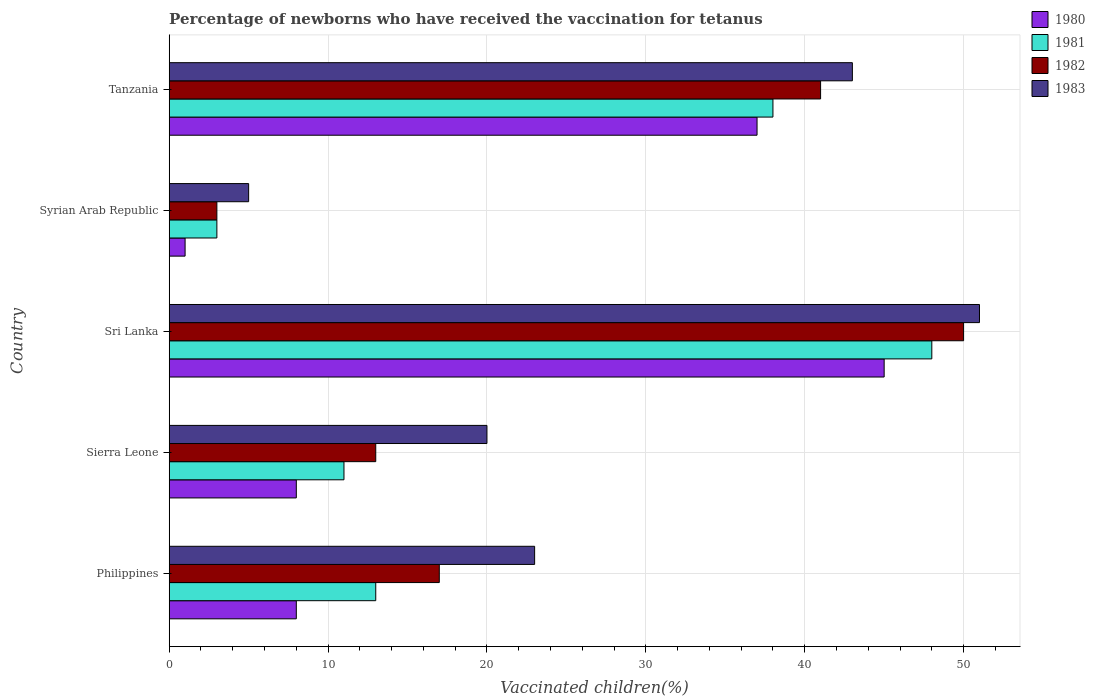Are the number of bars per tick equal to the number of legend labels?
Ensure brevity in your answer.  Yes. How many bars are there on the 1st tick from the bottom?
Your answer should be very brief. 4. What is the label of the 3rd group of bars from the top?
Your answer should be compact. Sri Lanka. In which country was the percentage of vaccinated children in 1983 maximum?
Offer a very short reply. Sri Lanka. In which country was the percentage of vaccinated children in 1982 minimum?
Keep it short and to the point. Syrian Arab Republic. What is the total percentage of vaccinated children in 1982 in the graph?
Your answer should be compact. 124. What is the difference between the percentage of vaccinated children in 1980 in Sri Lanka and the percentage of vaccinated children in 1981 in Philippines?
Ensure brevity in your answer.  32. What is the average percentage of vaccinated children in 1983 per country?
Your answer should be very brief. 28.4. In how many countries, is the percentage of vaccinated children in 1983 greater than 34 %?
Give a very brief answer. 2. What is the ratio of the percentage of vaccinated children in 1983 in Philippines to that in Tanzania?
Your answer should be very brief. 0.53. Is the percentage of vaccinated children in 1981 in Sierra Leone less than that in Tanzania?
Give a very brief answer. Yes. Is the difference between the percentage of vaccinated children in 1981 in Sri Lanka and Tanzania greater than the difference between the percentage of vaccinated children in 1982 in Sri Lanka and Tanzania?
Provide a succinct answer. Yes. What is the difference between the highest and the second highest percentage of vaccinated children in 1982?
Make the answer very short. 9. What is the difference between the highest and the lowest percentage of vaccinated children in 1983?
Your answer should be compact. 46. In how many countries, is the percentage of vaccinated children in 1981 greater than the average percentage of vaccinated children in 1981 taken over all countries?
Provide a short and direct response. 2. Is it the case that in every country, the sum of the percentage of vaccinated children in 1981 and percentage of vaccinated children in 1982 is greater than the sum of percentage of vaccinated children in 1980 and percentage of vaccinated children in 1983?
Make the answer very short. No. What does the 3rd bar from the top in Philippines represents?
Ensure brevity in your answer.  1981. What does the 1st bar from the bottom in Philippines represents?
Ensure brevity in your answer.  1980. Is it the case that in every country, the sum of the percentage of vaccinated children in 1983 and percentage of vaccinated children in 1980 is greater than the percentage of vaccinated children in 1981?
Provide a succinct answer. Yes. How many bars are there?
Your answer should be compact. 20. What is the difference between two consecutive major ticks on the X-axis?
Your answer should be compact. 10. Are the values on the major ticks of X-axis written in scientific E-notation?
Offer a terse response. No. Does the graph contain grids?
Give a very brief answer. Yes. How many legend labels are there?
Give a very brief answer. 4. How are the legend labels stacked?
Offer a terse response. Vertical. What is the title of the graph?
Offer a very short reply. Percentage of newborns who have received the vaccination for tetanus. What is the label or title of the X-axis?
Keep it short and to the point. Vaccinated children(%). What is the Vaccinated children(%) in 1982 in Philippines?
Make the answer very short. 17. What is the Vaccinated children(%) of 1983 in Philippines?
Offer a terse response. 23. What is the Vaccinated children(%) in 1980 in Sierra Leone?
Ensure brevity in your answer.  8. What is the Vaccinated children(%) in 1983 in Sierra Leone?
Ensure brevity in your answer.  20. What is the Vaccinated children(%) of 1980 in Sri Lanka?
Ensure brevity in your answer.  45. What is the Vaccinated children(%) in 1981 in Sri Lanka?
Make the answer very short. 48. What is the Vaccinated children(%) of 1982 in Sri Lanka?
Your answer should be compact. 50. What is the Vaccinated children(%) of 1981 in Syrian Arab Republic?
Offer a terse response. 3. What is the Vaccinated children(%) in 1982 in Syrian Arab Republic?
Your response must be concise. 3. What is the Vaccinated children(%) in 1981 in Tanzania?
Your response must be concise. 38. What is the Vaccinated children(%) in 1983 in Tanzania?
Provide a succinct answer. 43. Across all countries, what is the maximum Vaccinated children(%) in 1982?
Offer a terse response. 50. Across all countries, what is the maximum Vaccinated children(%) in 1983?
Make the answer very short. 51. What is the total Vaccinated children(%) of 1981 in the graph?
Your answer should be compact. 113. What is the total Vaccinated children(%) of 1982 in the graph?
Offer a very short reply. 124. What is the total Vaccinated children(%) of 1983 in the graph?
Your answer should be very brief. 142. What is the difference between the Vaccinated children(%) in 1981 in Philippines and that in Sierra Leone?
Offer a very short reply. 2. What is the difference between the Vaccinated children(%) of 1983 in Philippines and that in Sierra Leone?
Offer a very short reply. 3. What is the difference between the Vaccinated children(%) in 1980 in Philippines and that in Sri Lanka?
Provide a short and direct response. -37. What is the difference between the Vaccinated children(%) of 1981 in Philippines and that in Sri Lanka?
Provide a short and direct response. -35. What is the difference between the Vaccinated children(%) in 1982 in Philippines and that in Sri Lanka?
Offer a very short reply. -33. What is the difference between the Vaccinated children(%) in 1981 in Philippines and that in Syrian Arab Republic?
Keep it short and to the point. 10. What is the difference between the Vaccinated children(%) of 1982 in Philippines and that in Syrian Arab Republic?
Offer a very short reply. 14. What is the difference between the Vaccinated children(%) of 1980 in Philippines and that in Tanzania?
Offer a very short reply. -29. What is the difference between the Vaccinated children(%) of 1982 in Philippines and that in Tanzania?
Ensure brevity in your answer.  -24. What is the difference between the Vaccinated children(%) in 1983 in Philippines and that in Tanzania?
Provide a short and direct response. -20. What is the difference between the Vaccinated children(%) of 1980 in Sierra Leone and that in Sri Lanka?
Offer a very short reply. -37. What is the difference between the Vaccinated children(%) of 1981 in Sierra Leone and that in Sri Lanka?
Provide a succinct answer. -37. What is the difference between the Vaccinated children(%) of 1982 in Sierra Leone and that in Sri Lanka?
Give a very brief answer. -37. What is the difference between the Vaccinated children(%) of 1983 in Sierra Leone and that in Sri Lanka?
Your response must be concise. -31. What is the difference between the Vaccinated children(%) in 1980 in Sierra Leone and that in Syrian Arab Republic?
Keep it short and to the point. 7. What is the difference between the Vaccinated children(%) in 1980 in Sri Lanka and that in Syrian Arab Republic?
Provide a succinct answer. 44. What is the difference between the Vaccinated children(%) in 1982 in Sri Lanka and that in Syrian Arab Republic?
Ensure brevity in your answer.  47. What is the difference between the Vaccinated children(%) in 1980 in Sri Lanka and that in Tanzania?
Keep it short and to the point. 8. What is the difference between the Vaccinated children(%) of 1982 in Sri Lanka and that in Tanzania?
Offer a very short reply. 9. What is the difference between the Vaccinated children(%) of 1980 in Syrian Arab Republic and that in Tanzania?
Offer a terse response. -36. What is the difference between the Vaccinated children(%) of 1981 in Syrian Arab Republic and that in Tanzania?
Ensure brevity in your answer.  -35. What is the difference between the Vaccinated children(%) in 1982 in Syrian Arab Republic and that in Tanzania?
Ensure brevity in your answer.  -38. What is the difference between the Vaccinated children(%) in 1983 in Syrian Arab Republic and that in Tanzania?
Offer a terse response. -38. What is the difference between the Vaccinated children(%) of 1980 in Philippines and the Vaccinated children(%) of 1982 in Sierra Leone?
Provide a succinct answer. -5. What is the difference between the Vaccinated children(%) in 1981 in Philippines and the Vaccinated children(%) in 1982 in Sierra Leone?
Make the answer very short. 0. What is the difference between the Vaccinated children(%) in 1981 in Philippines and the Vaccinated children(%) in 1983 in Sierra Leone?
Give a very brief answer. -7. What is the difference between the Vaccinated children(%) of 1982 in Philippines and the Vaccinated children(%) of 1983 in Sierra Leone?
Provide a succinct answer. -3. What is the difference between the Vaccinated children(%) in 1980 in Philippines and the Vaccinated children(%) in 1981 in Sri Lanka?
Provide a succinct answer. -40. What is the difference between the Vaccinated children(%) in 1980 in Philippines and the Vaccinated children(%) in 1982 in Sri Lanka?
Give a very brief answer. -42. What is the difference between the Vaccinated children(%) of 1980 in Philippines and the Vaccinated children(%) of 1983 in Sri Lanka?
Your response must be concise. -43. What is the difference between the Vaccinated children(%) in 1981 in Philippines and the Vaccinated children(%) in 1982 in Sri Lanka?
Make the answer very short. -37. What is the difference between the Vaccinated children(%) of 1981 in Philippines and the Vaccinated children(%) of 1983 in Sri Lanka?
Make the answer very short. -38. What is the difference between the Vaccinated children(%) of 1982 in Philippines and the Vaccinated children(%) of 1983 in Sri Lanka?
Your answer should be very brief. -34. What is the difference between the Vaccinated children(%) of 1980 in Philippines and the Vaccinated children(%) of 1982 in Syrian Arab Republic?
Your answer should be compact. 5. What is the difference between the Vaccinated children(%) in 1980 in Philippines and the Vaccinated children(%) in 1983 in Syrian Arab Republic?
Your response must be concise. 3. What is the difference between the Vaccinated children(%) in 1981 in Philippines and the Vaccinated children(%) in 1982 in Syrian Arab Republic?
Your response must be concise. 10. What is the difference between the Vaccinated children(%) of 1980 in Philippines and the Vaccinated children(%) of 1982 in Tanzania?
Give a very brief answer. -33. What is the difference between the Vaccinated children(%) in 1980 in Philippines and the Vaccinated children(%) in 1983 in Tanzania?
Keep it short and to the point. -35. What is the difference between the Vaccinated children(%) of 1981 in Philippines and the Vaccinated children(%) of 1982 in Tanzania?
Offer a terse response. -28. What is the difference between the Vaccinated children(%) of 1981 in Philippines and the Vaccinated children(%) of 1983 in Tanzania?
Provide a short and direct response. -30. What is the difference between the Vaccinated children(%) in 1982 in Philippines and the Vaccinated children(%) in 1983 in Tanzania?
Ensure brevity in your answer.  -26. What is the difference between the Vaccinated children(%) in 1980 in Sierra Leone and the Vaccinated children(%) in 1982 in Sri Lanka?
Make the answer very short. -42. What is the difference between the Vaccinated children(%) of 1980 in Sierra Leone and the Vaccinated children(%) of 1983 in Sri Lanka?
Give a very brief answer. -43. What is the difference between the Vaccinated children(%) in 1981 in Sierra Leone and the Vaccinated children(%) in 1982 in Sri Lanka?
Ensure brevity in your answer.  -39. What is the difference between the Vaccinated children(%) in 1981 in Sierra Leone and the Vaccinated children(%) in 1983 in Sri Lanka?
Your answer should be very brief. -40. What is the difference between the Vaccinated children(%) of 1982 in Sierra Leone and the Vaccinated children(%) of 1983 in Sri Lanka?
Provide a succinct answer. -38. What is the difference between the Vaccinated children(%) of 1980 in Sierra Leone and the Vaccinated children(%) of 1981 in Syrian Arab Republic?
Make the answer very short. 5. What is the difference between the Vaccinated children(%) of 1981 in Sierra Leone and the Vaccinated children(%) of 1982 in Syrian Arab Republic?
Make the answer very short. 8. What is the difference between the Vaccinated children(%) in 1980 in Sierra Leone and the Vaccinated children(%) in 1982 in Tanzania?
Ensure brevity in your answer.  -33. What is the difference between the Vaccinated children(%) in 1980 in Sierra Leone and the Vaccinated children(%) in 1983 in Tanzania?
Offer a terse response. -35. What is the difference between the Vaccinated children(%) in 1981 in Sierra Leone and the Vaccinated children(%) in 1983 in Tanzania?
Ensure brevity in your answer.  -32. What is the difference between the Vaccinated children(%) in 1982 in Sierra Leone and the Vaccinated children(%) in 1983 in Tanzania?
Keep it short and to the point. -30. What is the difference between the Vaccinated children(%) in 1980 in Sri Lanka and the Vaccinated children(%) in 1981 in Syrian Arab Republic?
Make the answer very short. 42. What is the difference between the Vaccinated children(%) of 1980 in Sri Lanka and the Vaccinated children(%) of 1982 in Syrian Arab Republic?
Offer a very short reply. 42. What is the difference between the Vaccinated children(%) of 1982 in Sri Lanka and the Vaccinated children(%) of 1983 in Syrian Arab Republic?
Offer a terse response. 45. What is the difference between the Vaccinated children(%) in 1980 in Sri Lanka and the Vaccinated children(%) in 1983 in Tanzania?
Your response must be concise. 2. What is the difference between the Vaccinated children(%) in 1981 in Sri Lanka and the Vaccinated children(%) in 1982 in Tanzania?
Your answer should be very brief. 7. What is the difference between the Vaccinated children(%) of 1981 in Sri Lanka and the Vaccinated children(%) of 1983 in Tanzania?
Your answer should be very brief. 5. What is the difference between the Vaccinated children(%) of 1982 in Sri Lanka and the Vaccinated children(%) of 1983 in Tanzania?
Your response must be concise. 7. What is the difference between the Vaccinated children(%) of 1980 in Syrian Arab Republic and the Vaccinated children(%) of 1981 in Tanzania?
Provide a short and direct response. -37. What is the difference between the Vaccinated children(%) of 1980 in Syrian Arab Republic and the Vaccinated children(%) of 1983 in Tanzania?
Provide a succinct answer. -42. What is the difference between the Vaccinated children(%) in 1981 in Syrian Arab Republic and the Vaccinated children(%) in 1982 in Tanzania?
Offer a very short reply. -38. What is the average Vaccinated children(%) in 1980 per country?
Ensure brevity in your answer.  19.8. What is the average Vaccinated children(%) in 1981 per country?
Your response must be concise. 22.6. What is the average Vaccinated children(%) of 1982 per country?
Your answer should be compact. 24.8. What is the average Vaccinated children(%) of 1983 per country?
Keep it short and to the point. 28.4. What is the difference between the Vaccinated children(%) of 1980 and Vaccinated children(%) of 1981 in Philippines?
Your answer should be compact. -5. What is the difference between the Vaccinated children(%) of 1981 and Vaccinated children(%) of 1983 in Philippines?
Your answer should be very brief. -10. What is the difference between the Vaccinated children(%) in 1980 and Vaccinated children(%) in 1981 in Sierra Leone?
Make the answer very short. -3. What is the difference between the Vaccinated children(%) of 1980 and Vaccinated children(%) of 1982 in Sierra Leone?
Your answer should be compact. -5. What is the difference between the Vaccinated children(%) of 1980 and Vaccinated children(%) of 1983 in Sierra Leone?
Give a very brief answer. -12. What is the difference between the Vaccinated children(%) of 1982 and Vaccinated children(%) of 1983 in Sierra Leone?
Give a very brief answer. -7. What is the difference between the Vaccinated children(%) of 1980 and Vaccinated children(%) of 1981 in Sri Lanka?
Keep it short and to the point. -3. What is the difference between the Vaccinated children(%) of 1981 and Vaccinated children(%) of 1982 in Sri Lanka?
Ensure brevity in your answer.  -2. What is the difference between the Vaccinated children(%) of 1980 and Vaccinated children(%) of 1981 in Tanzania?
Provide a short and direct response. -1. What is the difference between the Vaccinated children(%) of 1980 and Vaccinated children(%) of 1983 in Tanzania?
Keep it short and to the point. -6. What is the ratio of the Vaccinated children(%) of 1981 in Philippines to that in Sierra Leone?
Ensure brevity in your answer.  1.18. What is the ratio of the Vaccinated children(%) of 1982 in Philippines to that in Sierra Leone?
Offer a terse response. 1.31. What is the ratio of the Vaccinated children(%) of 1983 in Philippines to that in Sierra Leone?
Your answer should be compact. 1.15. What is the ratio of the Vaccinated children(%) in 1980 in Philippines to that in Sri Lanka?
Your answer should be compact. 0.18. What is the ratio of the Vaccinated children(%) of 1981 in Philippines to that in Sri Lanka?
Provide a short and direct response. 0.27. What is the ratio of the Vaccinated children(%) in 1982 in Philippines to that in Sri Lanka?
Your response must be concise. 0.34. What is the ratio of the Vaccinated children(%) in 1983 in Philippines to that in Sri Lanka?
Provide a succinct answer. 0.45. What is the ratio of the Vaccinated children(%) of 1980 in Philippines to that in Syrian Arab Republic?
Offer a terse response. 8. What is the ratio of the Vaccinated children(%) in 1981 in Philippines to that in Syrian Arab Republic?
Provide a short and direct response. 4.33. What is the ratio of the Vaccinated children(%) of 1982 in Philippines to that in Syrian Arab Republic?
Ensure brevity in your answer.  5.67. What is the ratio of the Vaccinated children(%) of 1983 in Philippines to that in Syrian Arab Republic?
Ensure brevity in your answer.  4.6. What is the ratio of the Vaccinated children(%) in 1980 in Philippines to that in Tanzania?
Your answer should be very brief. 0.22. What is the ratio of the Vaccinated children(%) in 1981 in Philippines to that in Tanzania?
Provide a succinct answer. 0.34. What is the ratio of the Vaccinated children(%) of 1982 in Philippines to that in Tanzania?
Your answer should be compact. 0.41. What is the ratio of the Vaccinated children(%) of 1983 in Philippines to that in Tanzania?
Provide a short and direct response. 0.53. What is the ratio of the Vaccinated children(%) of 1980 in Sierra Leone to that in Sri Lanka?
Give a very brief answer. 0.18. What is the ratio of the Vaccinated children(%) of 1981 in Sierra Leone to that in Sri Lanka?
Offer a terse response. 0.23. What is the ratio of the Vaccinated children(%) in 1982 in Sierra Leone to that in Sri Lanka?
Keep it short and to the point. 0.26. What is the ratio of the Vaccinated children(%) in 1983 in Sierra Leone to that in Sri Lanka?
Keep it short and to the point. 0.39. What is the ratio of the Vaccinated children(%) in 1981 in Sierra Leone to that in Syrian Arab Republic?
Keep it short and to the point. 3.67. What is the ratio of the Vaccinated children(%) of 1982 in Sierra Leone to that in Syrian Arab Republic?
Offer a very short reply. 4.33. What is the ratio of the Vaccinated children(%) in 1980 in Sierra Leone to that in Tanzania?
Provide a succinct answer. 0.22. What is the ratio of the Vaccinated children(%) in 1981 in Sierra Leone to that in Tanzania?
Make the answer very short. 0.29. What is the ratio of the Vaccinated children(%) in 1982 in Sierra Leone to that in Tanzania?
Ensure brevity in your answer.  0.32. What is the ratio of the Vaccinated children(%) in 1983 in Sierra Leone to that in Tanzania?
Provide a short and direct response. 0.47. What is the ratio of the Vaccinated children(%) of 1981 in Sri Lanka to that in Syrian Arab Republic?
Ensure brevity in your answer.  16. What is the ratio of the Vaccinated children(%) in 1982 in Sri Lanka to that in Syrian Arab Republic?
Make the answer very short. 16.67. What is the ratio of the Vaccinated children(%) in 1983 in Sri Lanka to that in Syrian Arab Republic?
Provide a short and direct response. 10.2. What is the ratio of the Vaccinated children(%) of 1980 in Sri Lanka to that in Tanzania?
Offer a terse response. 1.22. What is the ratio of the Vaccinated children(%) of 1981 in Sri Lanka to that in Tanzania?
Provide a short and direct response. 1.26. What is the ratio of the Vaccinated children(%) of 1982 in Sri Lanka to that in Tanzania?
Ensure brevity in your answer.  1.22. What is the ratio of the Vaccinated children(%) of 1983 in Sri Lanka to that in Tanzania?
Offer a terse response. 1.19. What is the ratio of the Vaccinated children(%) of 1980 in Syrian Arab Republic to that in Tanzania?
Keep it short and to the point. 0.03. What is the ratio of the Vaccinated children(%) in 1981 in Syrian Arab Republic to that in Tanzania?
Provide a short and direct response. 0.08. What is the ratio of the Vaccinated children(%) in 1982 in Syrian Arab Republic to that in Tanzania?
Your response must be concise. 0.07. What is the ratio of the Vaccinated children(%) in 1983 in Syrian Arab Republic to that in Tanzania?
Provide a succinct answer. 0.12. What is the difference between the highest and the second highest Vaccinated children(%) of 1981?
Provide a short and direct response. 10. What is the difference between the highest and the second highest Vaccinated children(%) in 1982?
Offer a terse response. 9. What is the difference between the highest and the lowest Vaccinated children(%) of 1982?
Provide a succinct answer. 47. 